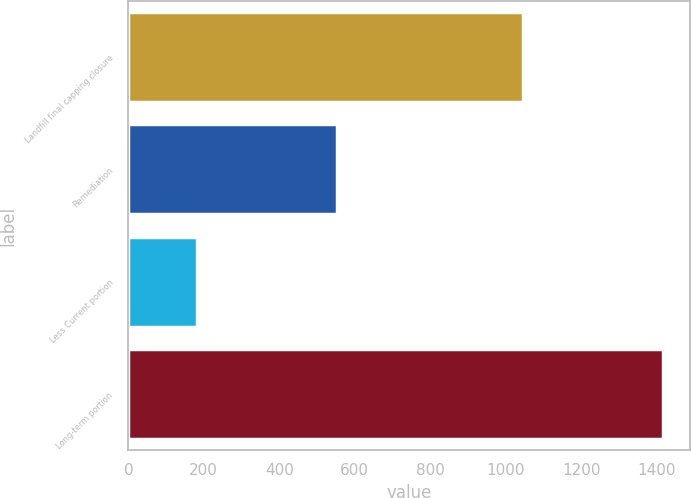Convert chart to OTSL. <chart><loc_0><loc_0><loc_500><loc_500><bar_chart><fcel>Landfill final capping closure<fcel>Remediation<fcel>Less Current portion<fcel>Long-term portion<nl><fcel>1046.5<fcel>552.1<fcel>182<fcel>1416.6<nl></chart> 